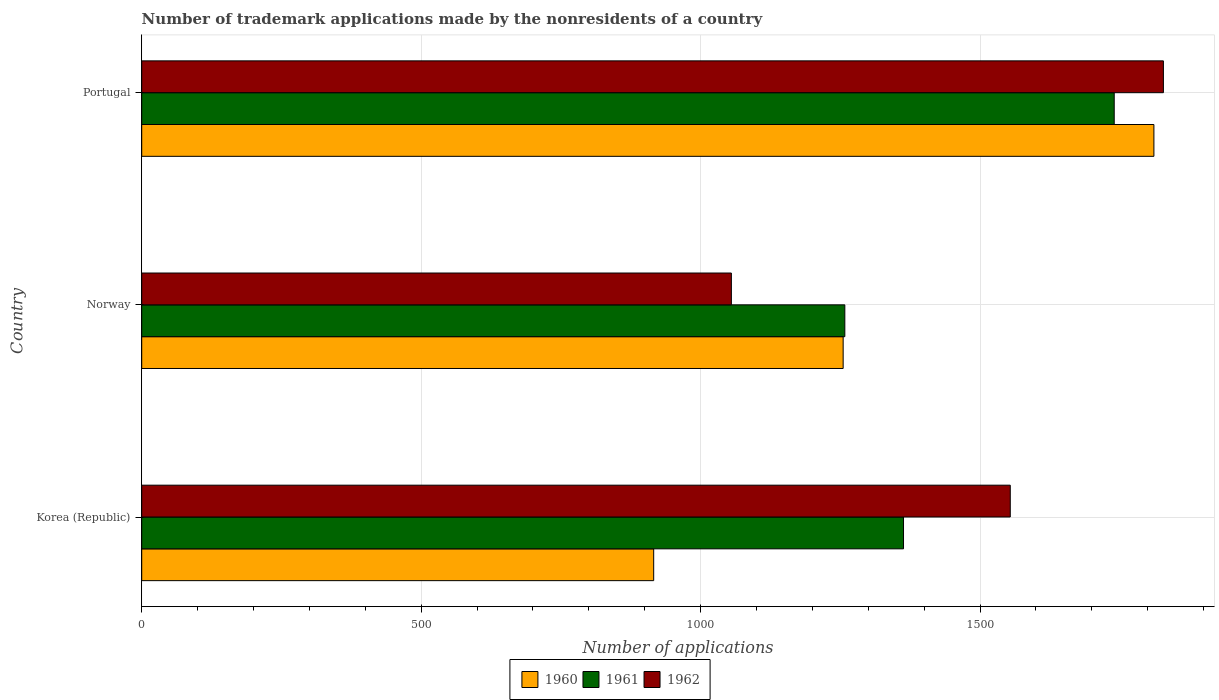How many different coloured bars are there?
Ensure brevity in your answer.  3. How many groups of bars are there?
Ensure brevity in your answer.  3. Are the number of bars per tick equal to the number of legend labels?
Give a very brief answer. Yes. How many bars are there on the 1st tick from the bottom?
Give a very brief answer. 3. What is the label of the 3rd group of bars from the top?
Ensure brevity in your answer.  Korea (Republic). In how many cases, is the number of bars for a given country not equal to the number of legend labels?
Give a very brief answer. 0. What is the number of trademark applications made by the nonresidents in 1962 in Norway?
Your answer should be compact. 1055. Across all countries, what is the maximum number of trademark applications made by the nonresidents in 1960?
Provide a short and direct response. 1811. Across all countries, what is the minimum number of trademark applications made by the nonresidents in 1960?
Offer a terse response. 916. What is the total number of trademark applications made by the nonresidents in 1962 in the graph?
Offer a terse response. 4437. What is the difference between the number of trademark applications made by the nonresidents in 1961 in Norway and that in Portugal?
Your answer should be compact. -482. What is the difference between the number of trademark applications made by the nonresidents in 1961 in Norway and the number of trademark applications made by the nonresidents in 1962 in Korea (Republic)?
Your response must be concise. -296. What is the average number of trademark applications made by the nonresidents in 1962 per country?
Provide a short and direct response. 1479. What is the ratio of the number of trademark applications made by the nonresidents in 1960 in Korea (Republic) to that in Portugal?
Your answer should be very brief. 0.51. Is the difference between the number of trademark applications made by the nonresidents in 1960 in Korea (Republic) and Norway greater than the difference between the number of trademark applications made by the nonresidents in 1962 in Korea (Republic) and Norway?
Provide a short and direct response. No. What is the difference between the highest and the second highest number of trademark applications made by the nonresidents in 1960?
Make the answer very short. 556. What is the difference between the highest and the lowest number of trademark applications made by the nonresidents in 1961?
Keep it short and to the point. 482. Is the sum of the number of trademark applications made by the nonresidents in 1962 in Korea (Republic) and Portugal greater than the maximum number of trademark applications made by the nonresidents in 1960 across all countries?
Make the answer very short. Yes. Are all the bars in the graph horizontal?
Provide a succinct answer. Yes. What is the difference between two consecutive major ticks on the X-axis?
Ensure brevity in your answer.  500. Does the graph contain grids?
Your response must be concise. Yes. Where does the legend appear in the graph?
Make the answer very short. Bottom center. How many legend labels are there?
Make the answer very short. 3. What is the title of the graph?
Offer a very short reply. Number of trademark applications made by the nonresidents of a country. What is the label or title of the X-axis?
Your answer should be very brief. Number of applications. What is the label or title of the Y-axis?
Provide a short and direct response. Country. What is the Number of applications in 1960 in Korea (Republic)?
Make the answer very short. 916. What is the Number of applications of 1961 in Korea (Republic)?
Your response must be concise. 1363. What is the Number of applications in 1962 in Korea (Republic)?
Your answer should be very brief. 1554. What is the Number of applications in 1960 in Norway?
Offer a terse response. 1255. What is the Number of applications in 1961 in Norway?
Keep it short and to the point. 1258. What is the Number of applications in 1962 in Norway?
Your answer should be very brief. 1055. What is the Number of applications in 1960 in Portugal?
Offer a terse response. 1811. What is the Number of applications in 1961 in Portugal?
Offer a terse response. 1740. What is the Number of applications of 1962 in Portugal?
Ensure brevity in your answer.  1828. Across all countries, what is the maximum Number of applications of 1960?
Offer a terse response. 1811. Across all countries, what is the maximum Number of applications in 1961?
Your response must be concise. 1740. Across all countries, what is the maximum Number of applications of 1962?
Provide a short and direct response. 1828. Across all countries, what is the minimum Number of applications in 1960?
Make the answer very short. 916. Across all countries, what is the minimum Number of applications in 1961?
Ensure brevity in your answer.  1258. Across all countries, what is the minimum Number of applications in 1962?
Your response must be concise. 1055. What is the total Number of applications of 1960 in the graph?
Offer a terse response. 3982. What is the total Number of applications of 1961 in the graph?
Keep it short and to the point. 4361. What is the total Number of applications of 1962 in the graph?
Your answer should be very brief. 4437. What is the difference between the Number of applications of 1960 in Korea (Republic) and that in Norway?
Provide a short and direct response. -339. What is the difference between the Number of applications in 1961 in Korea (Republic) and that in Norway?
Offer a very short reply. 105. What is the difference between the Number of applications of 1962 in Korea (Republic) and that in Norway?
Provide a short and direct response. 499. What is the difference between the Number of applications in 1960 in Korea (Republic) and that in Portugal?
Keep it short and to the point. -895. What is the difference between the Number of applications of 1961 in Korea (Republic) and that in Portugal?
Your response must be concise. -377. What is the difference between the Number of applications of 1962 in Korea (Republic) and that in Portugal?
Offer a very short reply. -274. What is the difference between the Number of applications in 1960 in Norway and that in Portugal?
Ensure brevity in your answer.  -556. What is the difference between the Number of applications of 1961 in Norway and that in Portugal?
Your response must be concise. -482. What is the difference between the Number of applications of 1962 in Norway and that in Portugal?
Give a very brief answer. -773. What is the difference between the Number of applications of 1960 in Korea (Republic) and the Number of applications of 1961 in Norway?
Give a very brief answer. -342. What is the difference between the Number of applications in 1960 in Korea (Republic) and the Number of applications in 1962 in Norway?
Offer a terse response. -139. What is the difference between the Number of applications of 1961 in Korea (Republic) and the Number of applications of 1962 in Norway?
Make the answer very short. 308. What is the difference between the Number of applications in 1960 in Korea (Republic) and the Number of applications in 1961 in Portugal?
Provide a short and direct response. -824. What is the difference between the Number of applications in 1960 in Korea (Republic) and the Number of applications in 1962 in Portugal?
Offer a terse response. -912. What is the difference between the Number of applications of 1961 in Korea (Republic) and the Number of applications of 1962 in Portugal?
Provide a succinct answer. -465. What is the difference between the Number of applications in 1960 in Norway and the Number of applications in 1961 in Portugal?
Offer a terse response. -485. What is the difference between the Number of applications in 1960 in Norway and the Number of applications in 1962 in Portugal?
Your response must be concise. -573. What is the difference between the Number of applications of 1961 in Norway and the Number of applications of 1962 in Portugal?
Your response must be concise. -570. What is the average Number of applications of 1960 per country?
Your response must be concise. 1327.33. What is the average Number of applications in 1961 per country?
Keep it short and to the point. 1453.67. What is the average Number of applications of 1962 per country?
Give a very brief answer. 1479. What is the difference between the Number of applications of 1960 and Number of applications of 1961 in Korea (Republic)?
Your answer should be compact. -447. What is the difference between the Number of applications of 1960 and Number of applications of 1962 in Korea (Republic)?
Keep it short and to the point. -638. What is the difference between the Number of applications of 1961 and Number of applications of 1962 in Korea (Republic)?
Your answer should be compact. -191. What is the difference between the Number of applications in 1960 and Number of applications in 1962 in Norway?
Your answer should be compact. 200. What is the difference between the Number of applications of 1961 and Number of applications of 1962 in Norway?
Your response must be concise. 203. What is the difference between the Number of applications in 1960 and Number of applications in 1962 in Portugal?
Your answer should be very brief. -17. What is the difference between the Number of applications in 1961 and Number of applications in 1962 in Portugal?
Give a very brief answer. -88. What is the ratio of the Number of applications of 1960 in Korea (Republic) to that in Norway?
Your answer should be very brief. 0.73. What is the ratio of the Number of applications of 1961 in Korea (Republic) to that in Norway?
Provide a succinct answer. 1.08. What is the ratio of the Number of applications of 1962 in Korea (Republic) to that in Norway?
Your answer should be compact. 1.47. What is the ratio of the Number of applications in 1960 in Korea (Republic) to that in Portugal?
Make the answer very short. 0.51. What is the ratio of the Number of applications of 1961 in Korea (Republic) to that in Portugal?
Offer a terse response. 0.78. What is the ratio of the Number of applications of 1962 in Korea (Republic) to that in Portugal?
Your response must be concise. 0.85. What is the ratio of the Number of applications in 1960 in Norway to that in Portugal?
Give a very brief answer. 0.69. What is the ratio of the Number of applications in 1961 in Norway to that in Portugal?
Make the answer very short. 0.72. What is the ratio of the Number of applications in 1962 in Norway to that in Portugal?
Your answer should be compact. 0.58. What is the difference between the highest and the second highest Number of applications of 1960?
Offer a very short reply. 556. What is the difference between the highest and the second highest Number of applications of 1961?
Provide a short and direct response. 377. What is the difference between the highest and the second highest Number of applications of 1962?
Make the answer very short. 274. What is the difference between the highest and the lowest Number of applications of 1960?
Make the answer very short. 895. What is the difference between the highest and the lowest Number of applications in 1961?
Offer a very short reply. 482. What is the difference between the highest and the lowest Number of applications in 1962?
Your answer should be very brief. 773. 